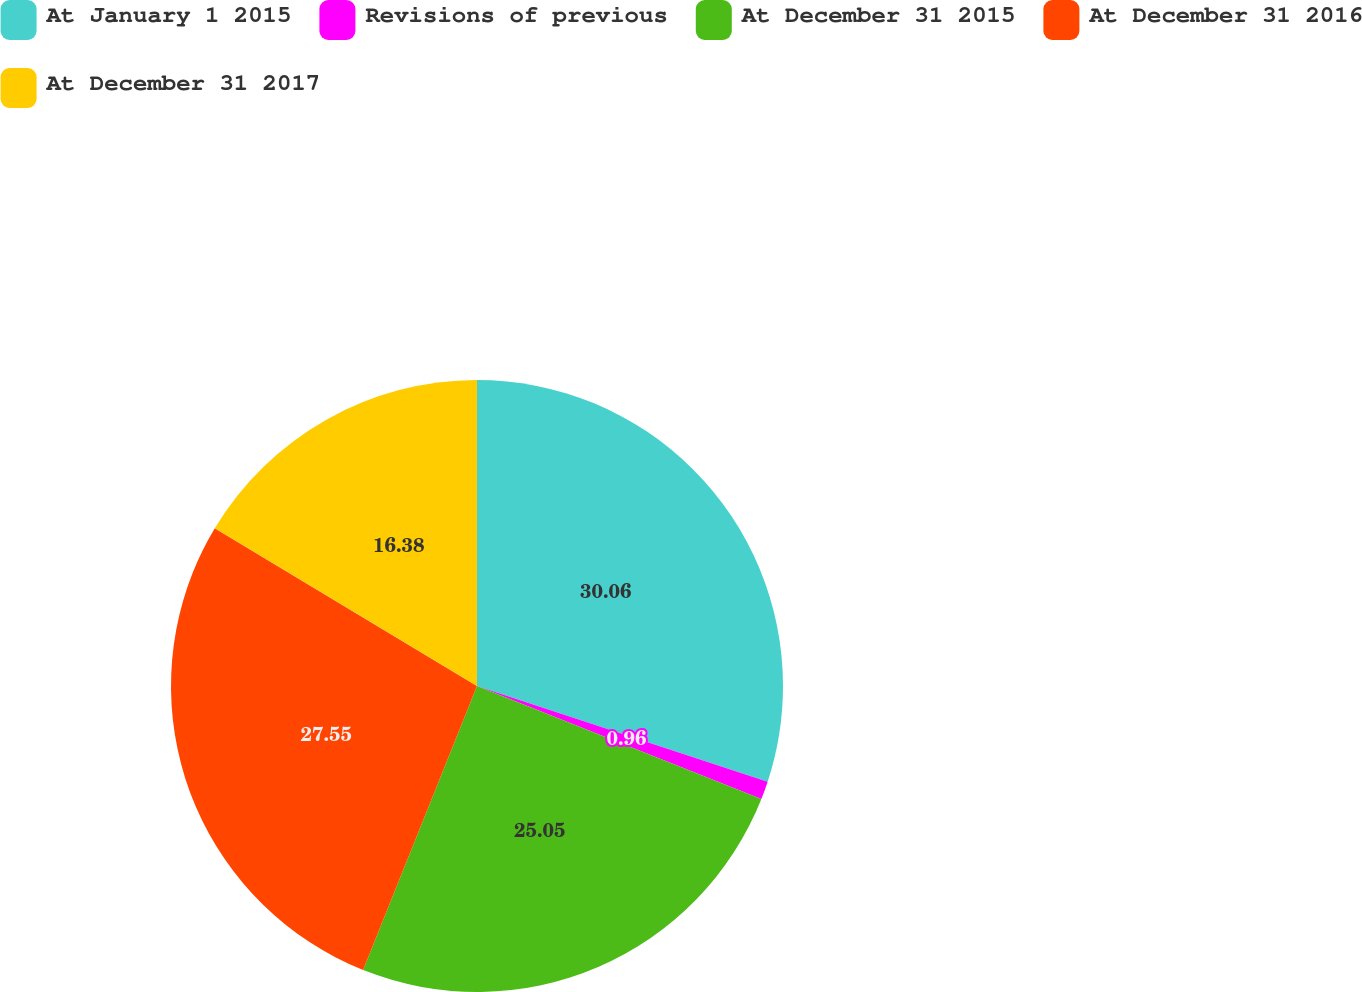Convert chart to OTSL. <chart><loc_0><loc_0><loc_500><loc_500><pie_chart><fcel>At January 1 2015<fcel>Revisions of previous<fcel>At December 31 2015<fcel>At December 31 2016<fcel>At December 31 2017<nl><fcel>30.06%<fcel>0.96%<fcel>25.05%<fcel>27.55%<fcel>16.38%<nl></chart> 